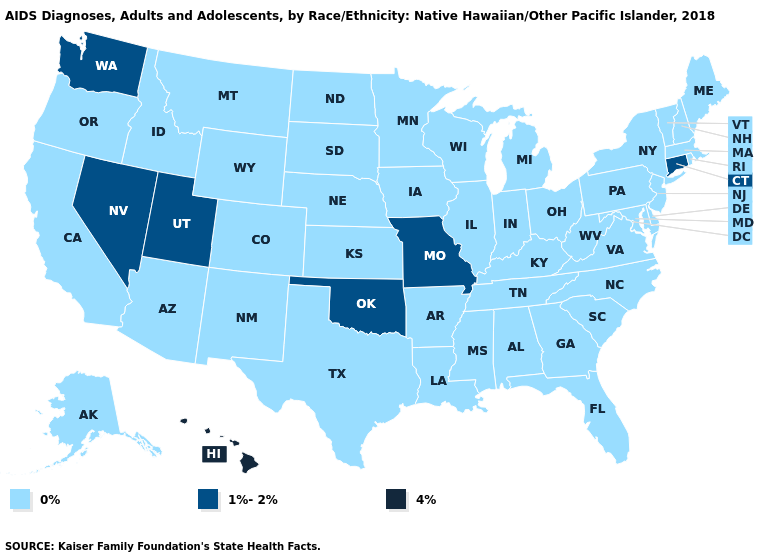Name the states that have a value in the range 1%-2%?
Give a very brief answer. Connecticut, Missouri, Nevada, Oklahoma, Utah, Washington. What is the highest value in states that border Maryland?
Concise answer only. 0%. Name the states that have a value in the range 0%?
Write a very short answer. Alabama, Alaska, Arizona, Arkansas, California, Colorado, Delaware, Florida, Georgia, Idaho, Illinois, Indiana, Iowa, Kansas, Kentucky, Louisiana, Maine, Maryland, Massachusetts, Michigan, Minnesota, Mississippi, Montana, Nebraska, New Hampshire, New Jersey, New Mexico, New York, North Carolina, North Dakota, Ohio, Oregon, Pennsylvania, Rhode Island, South Carolina, South Dakota, Tennessee, Texas, Vermont, Virginia, West Virginia, Wisconsin, Wyoming. What is the value of Illinois?
Answer briefly. 0%. Does Washington have a lower value than Hawaii?
Keep it brief. Yes. What is the value of Oregon?
Keep it brief. 0%. Is the legend a continuous bar?
Quick response, please. No. Name the states that have a value in the range 1%-2%?
Answer briefly. Connecticut, Missouri, Nevada, Oklahoma, Utah, Washington. Does Maine have the highest value in the Northeast?
Short answer required. No. Which states hav the highest value in the South?
Be succinct. Oklahoma. Does the first symbol in the legend represent the smallest category?
Concise answer only. Yes. What is the value of Wisconsin?
Keep it brief. 0%. Does Mississippi have a higher value than Pennsylvania?
Short answer required. No. 